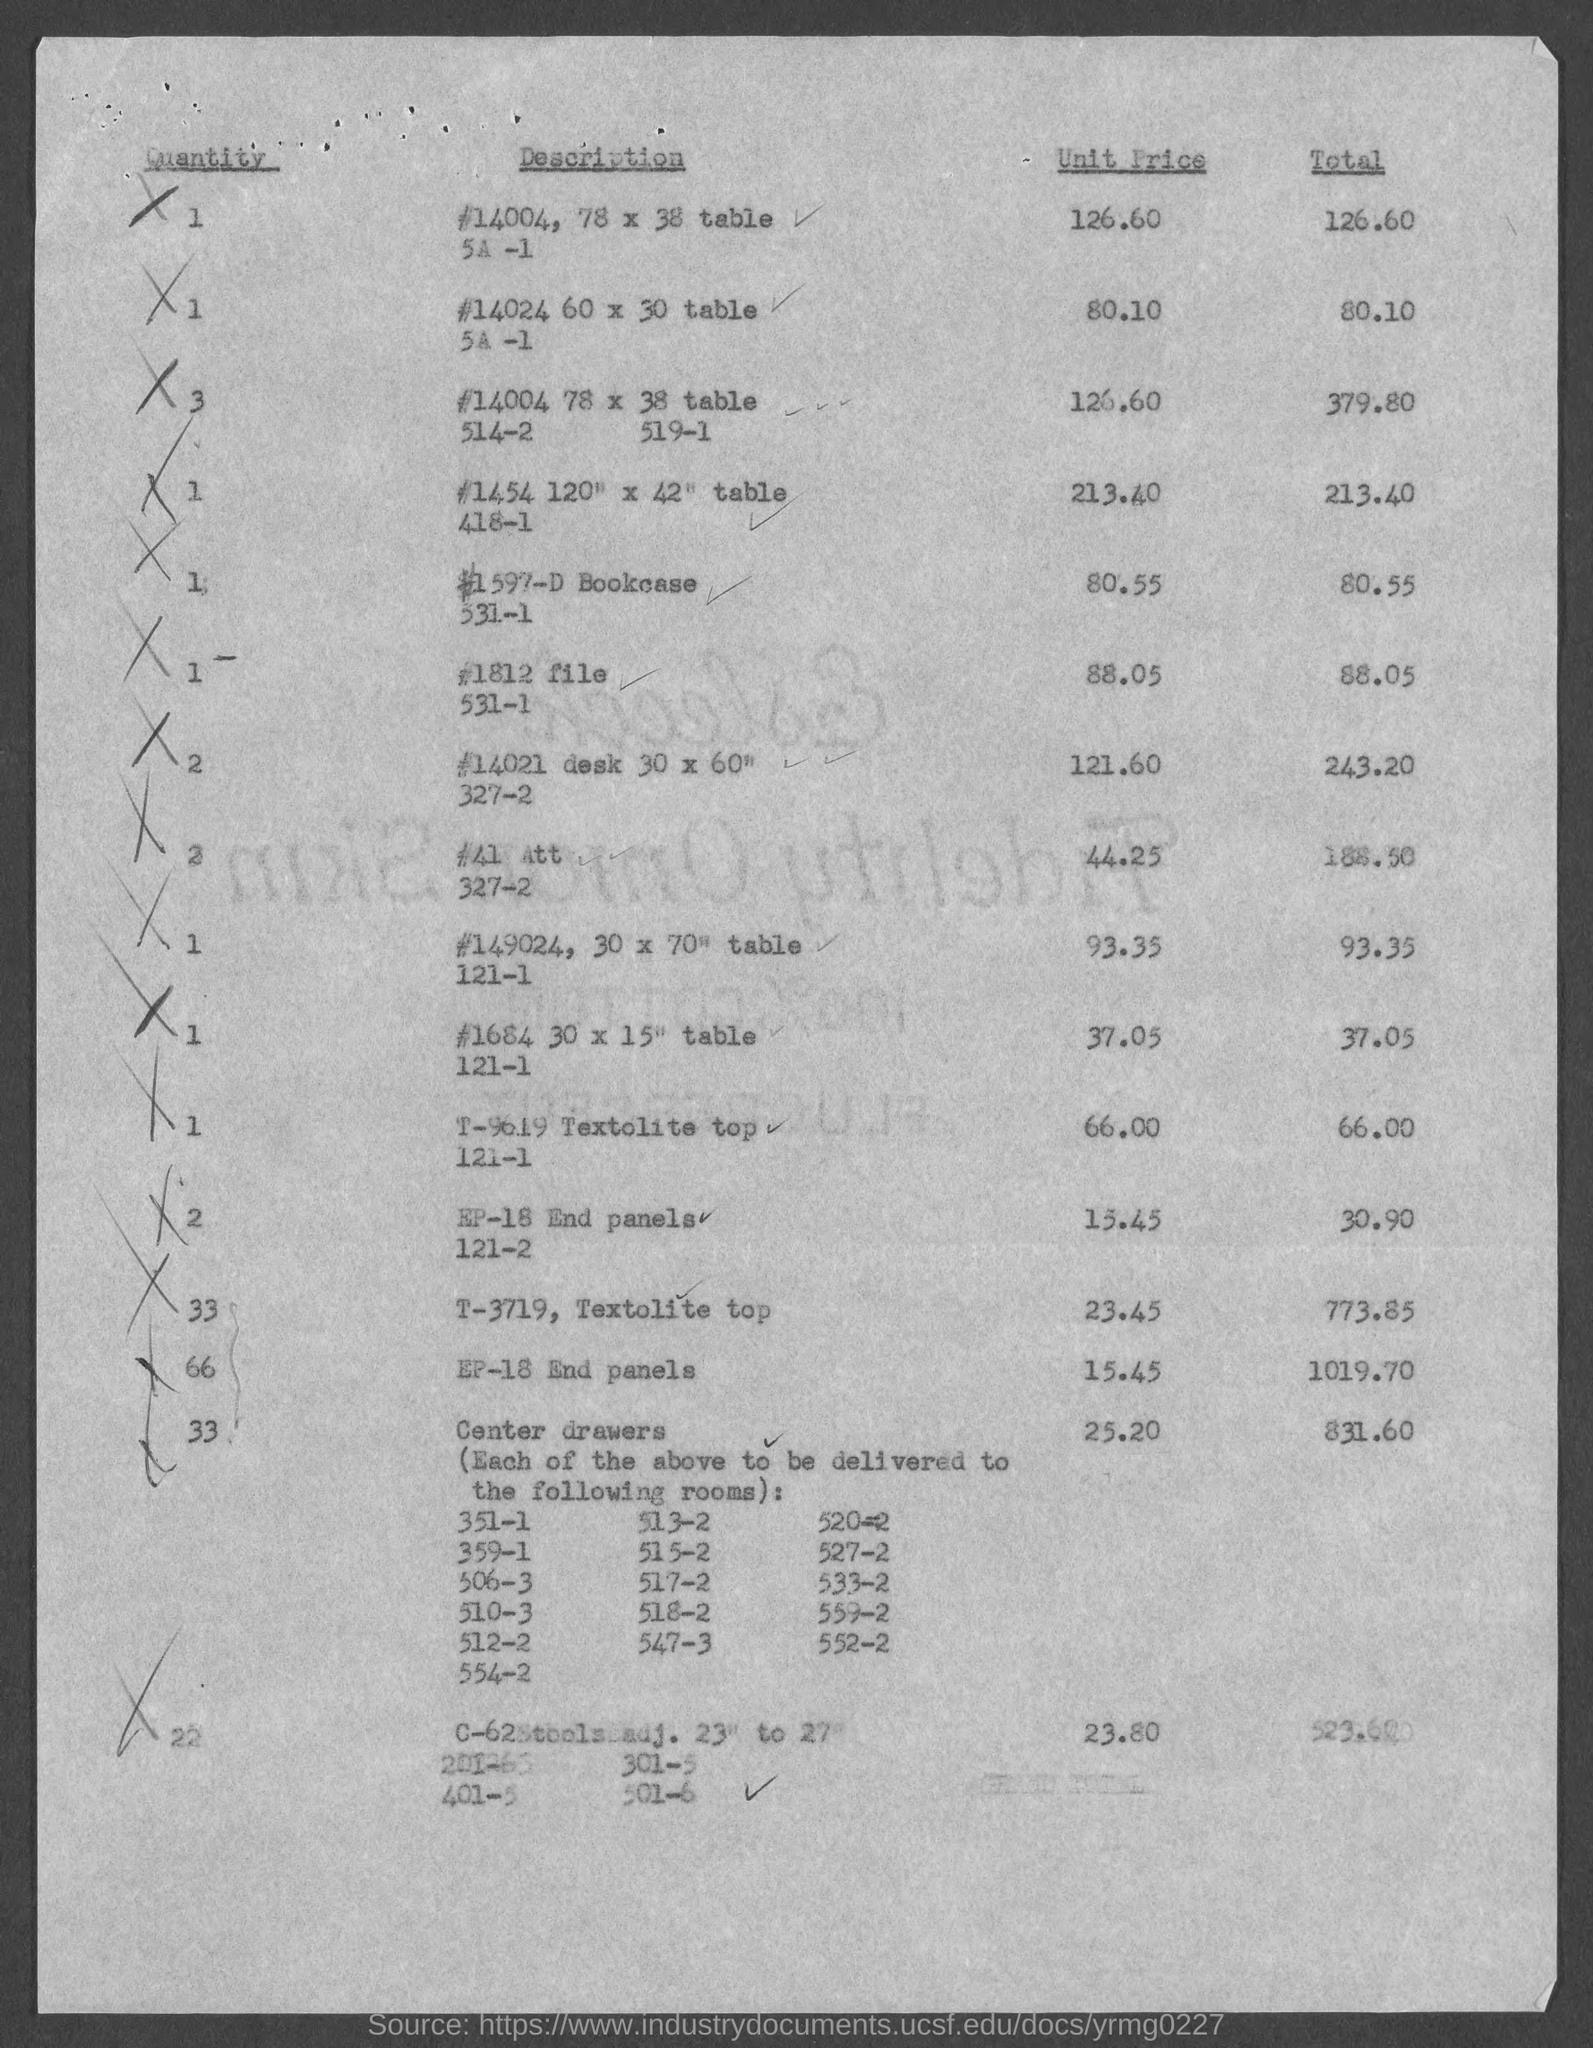What is the unit price in the first row of the table
Ensure brevity in your answer.  126.60. What is the quantity in the third row of the table?
Offer a very short reply. 3. What is the quantity in the last row?
Make the answer very short. 22. What is the table size in second row of description?
Your answer should be very brief. 60 x 30. What is the total value for end panels EP 18?
Provide a succinct answer. 1019.70. 